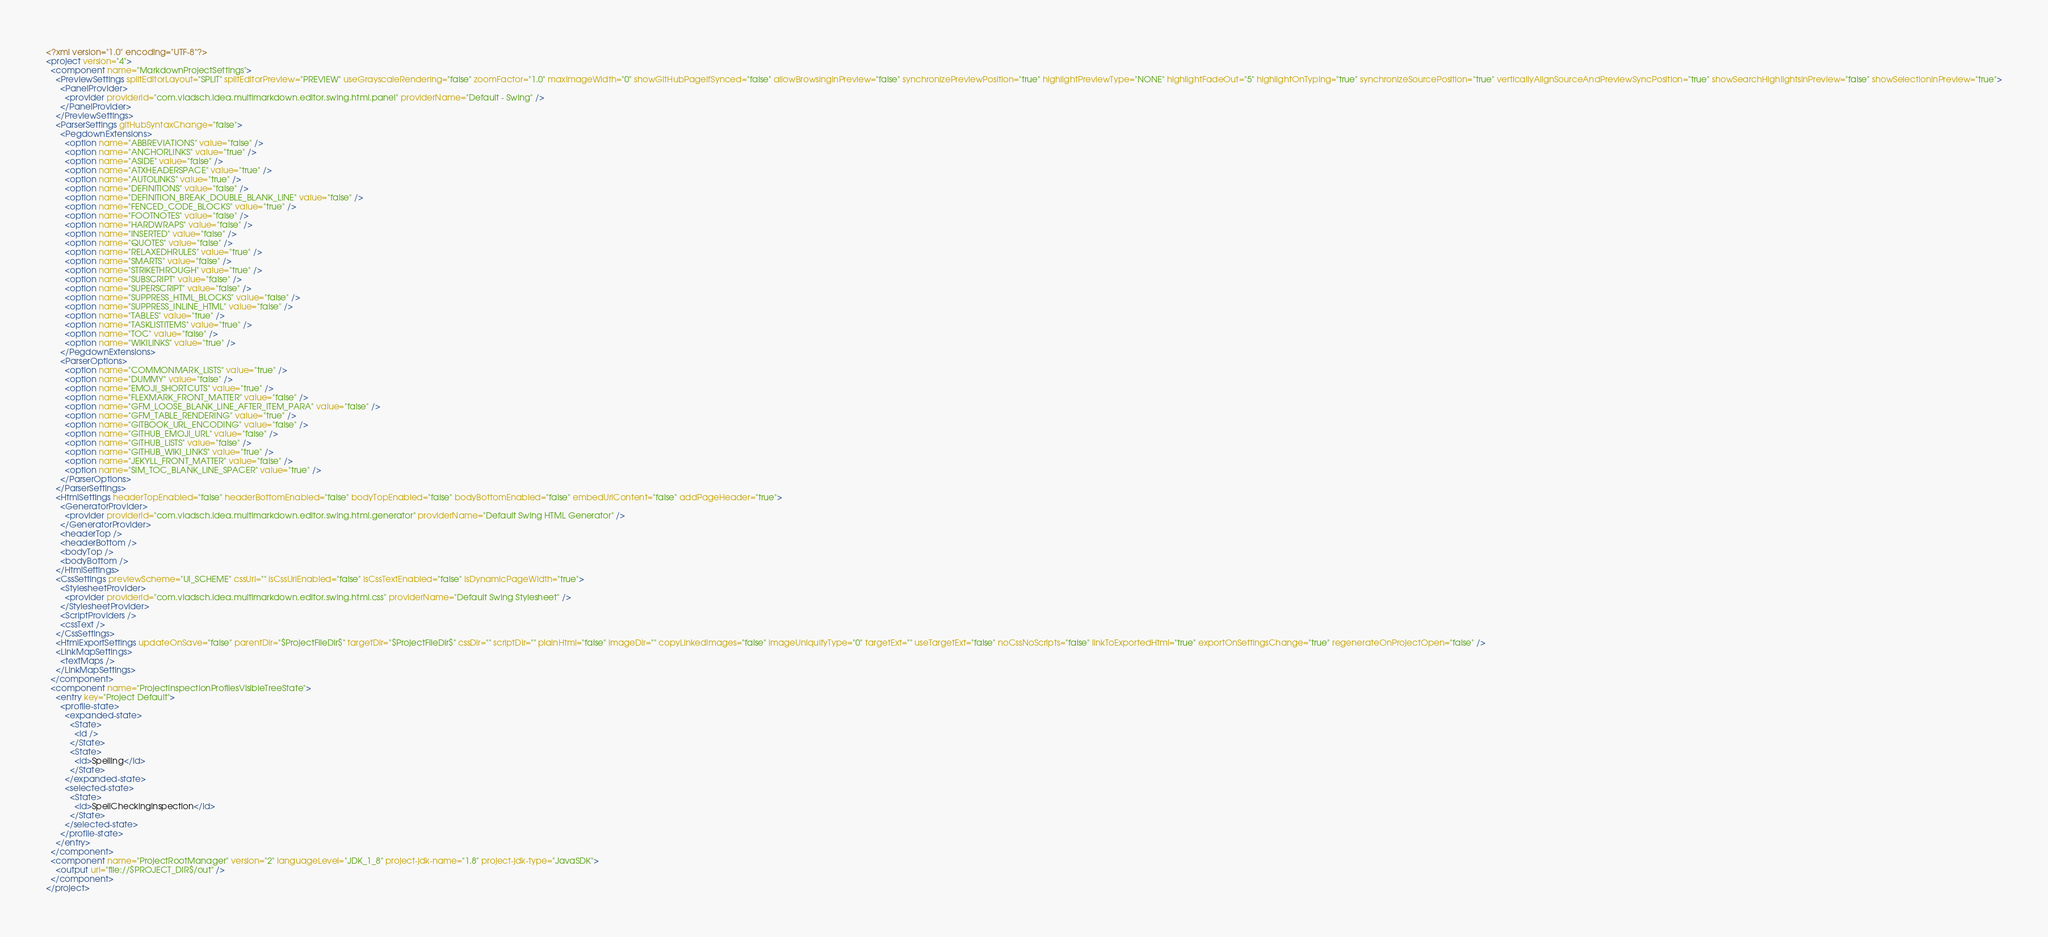Convert code to text. <code><loc_0><loc_0><loc_500><loc_500><_XML_><?xml version="1.0" encoding="UTF-8"?>
<project version="4">
  <component name="MarkdownProjectSettings">
    <PreviewSettings splitEditorLayout="SPLIT" splitEditorPreview="PREVIEW" useGrayscaleRendering="false" zoomFactor="1.0" maxImageWidth="0" showGitHubPageIfSynced="false" allowBrowsingInPreview="false" synchronizePreviewPosition="true" highlightPreviewType="NONE" highlightFadeOut="5" highlightOnTyping="true" synchronizeSourcePosition="true" verticallyAlignSourceAndPreviewSyncPosition="true" showSearchHighlightsInPreview="false" showSelectionInPreview="true">
      <PanelProvider>
        <provider providerId="com.vladsch.idea.multimarkdown.editor.swing.html.panel" providerName="Default - Swing" />
      </PanelProvider>
    </PreviewSettings>
    <ParserSettings gitHubSyntaxChange="false">
      <PegdownExtensions>
        <option name="ABBREVIATIONS" value="false" />
        <option name="ANCHORLINKS" value="true" />
        <option name="ASIDE" value="false" />
        <option name="ATXHEADERSPACE" value="true" />
        <option name="AUTOLINKS" value="true" />
        <option name="DEFINITIONS" value="false" />
        <option name="DEFINITION_BREAK_DOUBLE_BLANK_LINE" value="false" />
        <option name="FENCED_CODE_BLOCKS" value="true" />
        <option name="FOOTNOTES" value="false" />
        <option name="HARDWRAPS" value="false" />
        <option name="INSERTED" value="false" />
        <option name="QUOTES" value="false" />
        <option name="RELAXEDHRULES" value="true" />
        <option name="SMARTS" value="false" />
        <option name="STRIKETHROUGH" value="true" />
        <option name="SUBSCRIPT" value="false" />
        <option name="SUPERSCRIPT" value="false" />
        <option name="SUPPRESS_HTML_BLOCKS" value="false" />
        <option name="SUPPRESS_INLINE_HTML" value="false" />
        <option name="TABLES" value="true" />
        <option name="TASKLISTITEMS" value="true" />
        <option name="TOC" value="false" />
        <option name="WIKILINKS" value="true" />
      </PegdownExtensions>
      <ParserOptions>
        <option name="COMMONMARK_LISTS" value="true" />
        <option name="DUMMY" value="false" />
        <option name="EMOJI_SHORTCUTS" value="true" />
        <option name="FLEXMARK_FRONT_MATTER" value="false" />
        <option name="GFM_LOOSE_BLANK_LINE_AFTER_ITEM_PARA" value="false" />
        <option name="GFM_TABLE_RENDERING" value="true" />
        <option name="GITBOOK_URL_ENCODING" value="false" />
        <option name="GITHUB_EMOJI_URL" value="false" />
        <option name="GITHUB_LISTS" value="false" />
        <option name="GITHUB_WIKI_LINKS" value="true" />
        <option name="JEKYLL_FRONT_MATTER" value="false" />
        <option name="SIM_TOC_BLANK_LINE_SPACER" value="true" />
      </ParserOptions>
    </ParserSettings>
    <HtmlSettings headerTopEnabled="false" headerBottomEnabled="false" bodyTopEnabled="false" bodyBottomEnabled="false" embedUrlContent="false" addPageHeader="true">
      <GeneratorProvider>
        <provider providerId="com.vladsch.idea.multimarkdown.editor.swing.html.generator" providerName="Default Swing HTML Generator" />
      </GeneratorProvider>
      <headerTop />
      <headerBottom />
      <bodyTop />
      <bodyBottom />
    </HtmlSettings>
    <CssSettings previewScheme="UI_SCHEME" cssUri="" isCssUriEnabled="false" isCssTextEnabled="false" isDynamicPageWidth="true">
      <StylesheetProvider>
        <provider providerId="com.vladsch.idea.multimarkdown.editor.swing.html.css" providerName="Default Swing Stylesheet" />
      </StylesheetProvider>
      <ScriptProviders />
      <cssText />
    </CssSettings>
    <HtmlExportSettings updateOnSave="false" parentDir="$ProjectFileDir$" targetDir="$ProjectFileDir$" cssDir="" scriptDir="" plainHtml="false" imageDir="" copyLinkedImages="false" imageUniquifyType="0" targetExt="" useTargetExt="false" noCssNoScripts="false" linkToExportedHtml="true" exportOnSettingsChange="true" regenerateOnProjectOpen="false" />
    <LinkMapSettings>
      <textMaps />
    </LinkMapSettings>
  </component>
  <component name="ProjectInspectionProfilesVisibleTreeState">
    <entry key="Project Default">
      <profile-state>
        <expanded-state>
          <State>
            <id />
          </State>
          <State>
            <id>Spelling</id>
          </State>
        </expanded-state>
        <selected-state>
          <State>
            <id>SpellCheckingInspection</id>
          </State>
        </selected-state>
      </profile-state>
    </entry>
  </component>
  <component name="ProjectRootManager" version="2" languageLevel="JDK_1_8" project-jdk-name="1.8" project-jdk-type="JavaSDK">
    <output url="file://$PROJECT_DIR$/out" />
  </component>
</project></code> 